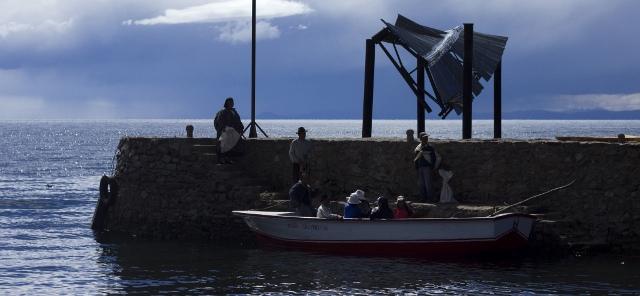Is the boy riding a boat?
Answer briefly. Yes. Is the photo in sepia?
Quick response, please. No. Are they trying to put the motorbike on the boat?
Be succinct. No. What is this person doing?
Give a very brief answer. Boating. How many people are standing on the boat?
Concise answer only. 1. What color are their jackets?
Write a very short answer. Black. What country does the flag represent?
Give a very brief answer. No flag. Is anyone on the dock?
Quick response, please. Yes. Is the water clear?
Be succinct. Yes. What time of day is it?
Answer briefly. Evening. What is on the boat?
Give a very brief answer. People. Are there people on the boat?
Give a very brief answer. Yes. How many boats are in the water?
Keep it brief. 1. What material was the boats made of?
Concise answer only. Wood. What type of boat is in the water?
Write a very short answer. Fishing. 